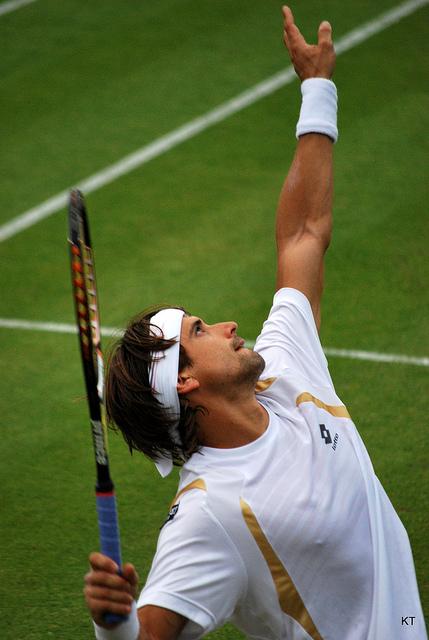What is he about to do?
Short answer required. Serve. What is the players name?
Short answer required. Federer. What is the man wearing on his head?
Give a very brief answer. Headband. 